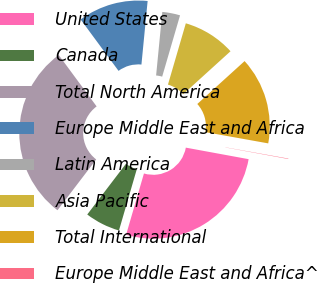<chart> <loc_0><loc_0><loc_500><loc_500><pie_chart><fcel>United States<fcel>Canada<fcel>Total North America<fcel>Europe Middle East and Africa<fcel>Latin America<fcel>Asia Pacific<fcel>Total International<fcel>Europe Middle East and Africa^<nl><fcel>26.62%<fcel>5.86%<fcel>29.52%<fcel>11.66%<fcel>2.97%<fcel>8.76%<fcel>14.55%<fcel>0.07%<nl></chart> 